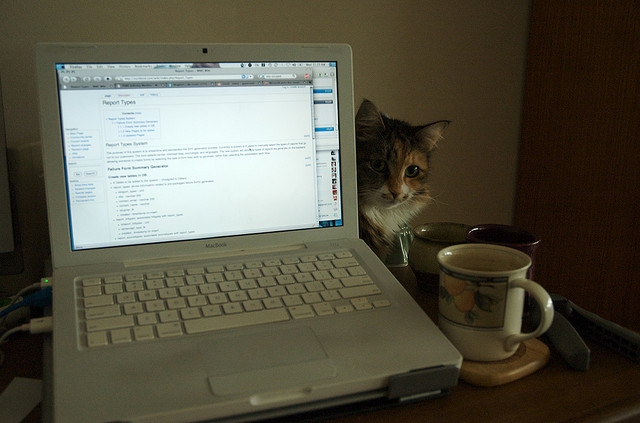<image>What is the cat's mouth open? It is not possible to determine why the cat's mouth is open. What kind of law is the book? There is no book in the image. Therefore it's impossible to determine the kind of law. Which mainframe is being shown on the laptop? I don't know which mainframe is being shown. It could be windows, internet browser, iframe, corporate, email, ios, macbook, ibm, or word. What is the cat's mouth open? I don't know why the cat's mouth is open. It could be because it is thirsty or wants to meow. What kind of law is the book? I don't know what kind of law is the book. However, it can be criminal, family or sharia law. Which mainframe is being shown on the laptop? I don't know which mainframe is being shown on the laptop. It can be any of ['windows', 'internet browser', 'iframe', 'corporate', 'email', 'ios', 'macbook', 'ibm', 'word']. 